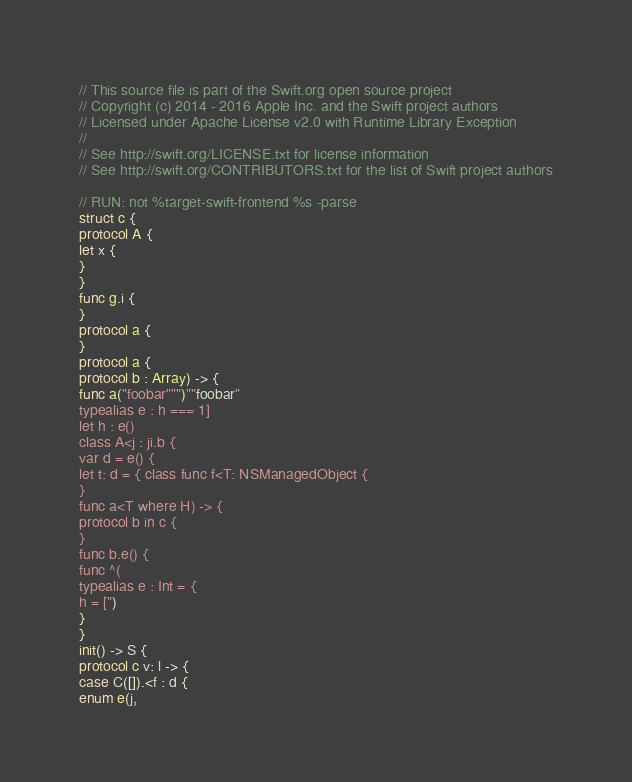Convert code to text. <code><loc_0><loc_0><loc_500><loc_500><_Swift_>// This source file is part of the Swift.org open source project
// Copyright (c) 2014 - 2016 Apple Inc. and the Swift project authors
// Licensed under Apache License v2.0 with Runtime Library Exception
//
// See http://swift.org/LICENSE.txt for license information
// See http://swift.org/CONTRIBUTORS.txt for the list of Swift project authors

// RUN: not %target-swift-frontend %s -parse
struct c {
protocol A {
let x {
}
}
func g.i {
}
protocol a {
}
protocol a {
protocol b : Array) -> {
func a("foobar""")""foobar"
typealias e : h === 1]
let h : e()
class A<j : ji.b {
var d = e() {
let t: d = { class func f<T: NSManagedObject {
}
func a<T where H) -> {
protocol b in c {
}
func b.e() {
func ^(
typealias e : Int = {
h = [")
}
}
init() -> S {
protocol c v: l -> {
case C([]).<f : d {
enum e(j,
</code> 